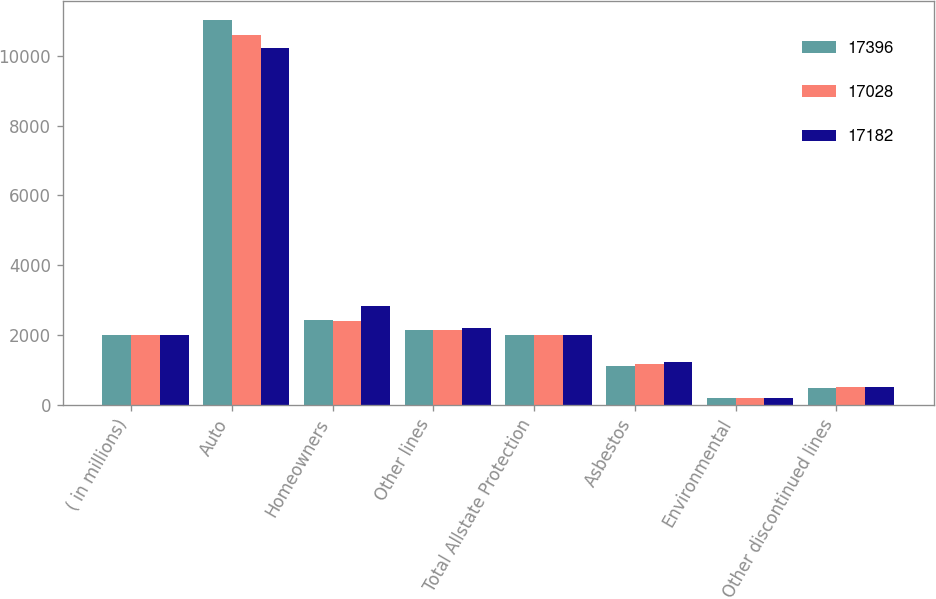Convert chart. <chart><loc_0><loc_0><loc_500><loc_500><stacked_bar_chart><ecel><fcel>( in millions)<fcel>Auto<fcel>Homeowners<fcel>Other lines<fcel>Total Allstate Protection<fcel>Asbestos<fcel>Environmental<fcel>Other discontinued lines<nl><fcel>17396<fcel>2010<fcel>11034<fcel>2442<fcel>2141<fcel>2009<fcel>1100<fcel>201<fcel>478<nl><fcel>17028<fcel>2009<fcel>10606<fcel>2399<fcel>2145<fcel>2009<fcel>1180<fcel>198<fcel>500<nl><fcel>17182<fcel>2008<fcel>10220<fcel>2824<fcel>2207<fcel>2009<fcel>1228<fcel>195<fcel>508<nl></chart> 